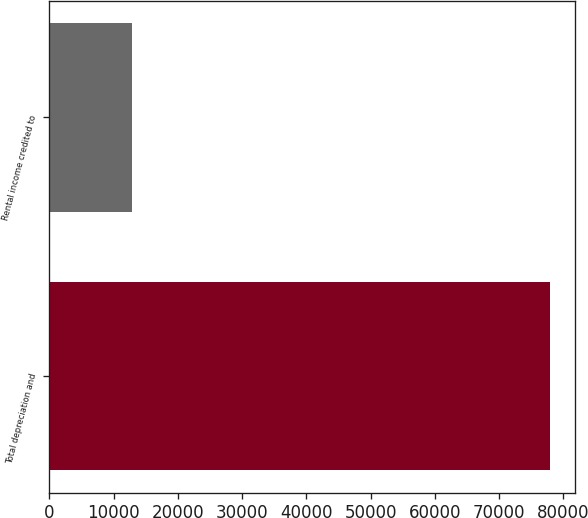Convert chart. <chart><loc_0><loc_0><loc_500><loc_500><bar_chart><fcel>Total depreciation and<fcel>Rental income credited to<nl><fcel>77956<fcel>12917<nl></chart> 